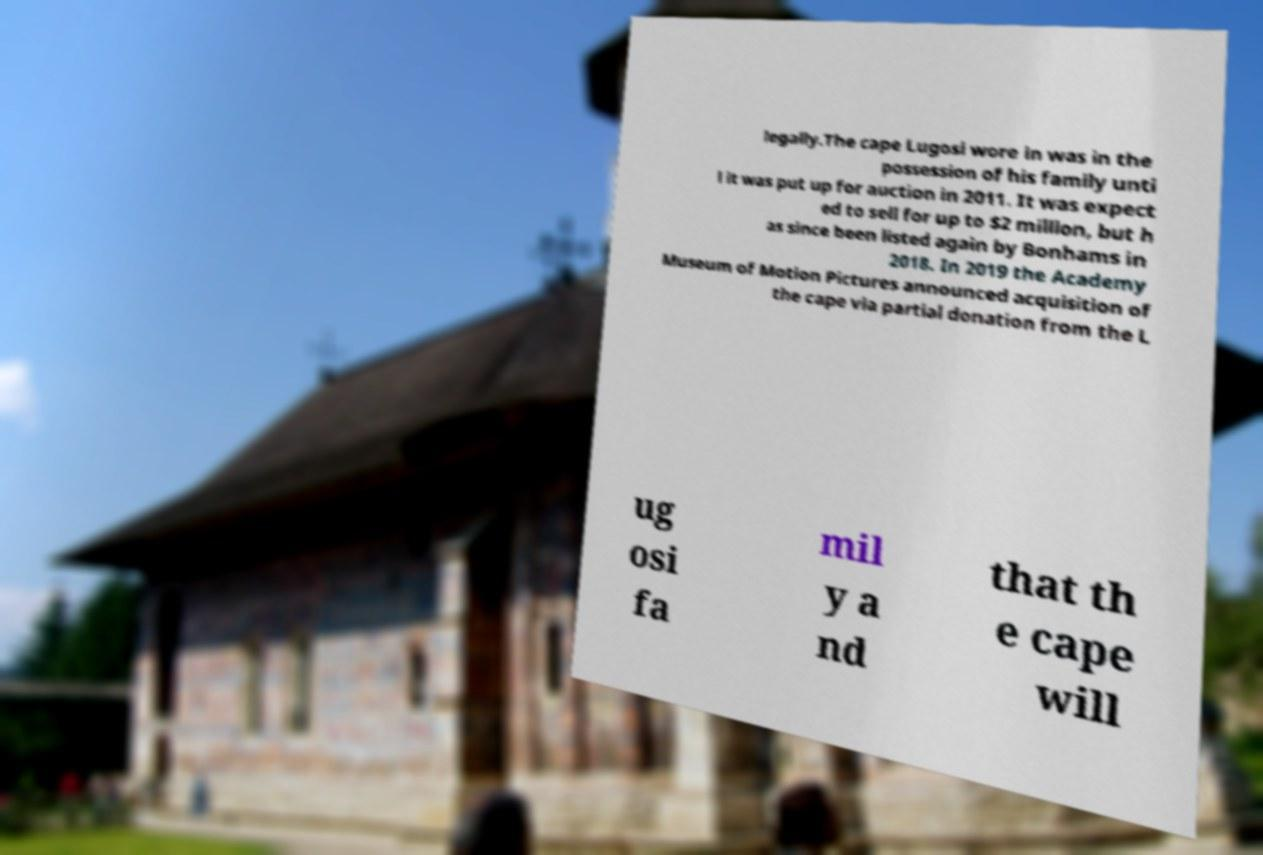There's text embedded in this image that I need extracted. Can you transcribe it verbatim? legally.The cape Lugosi wore in was in the possession of his family unti l it was put up for auction in 2011. It was expect ed to sell for up to $2 million, but h as since been listed again by Bonhams in 2018. In 2019 the Academy Museum of Motion Pictures announced acquisition of the cape via partial donation from the L ug osi fa mil y a nd that th e cape will 